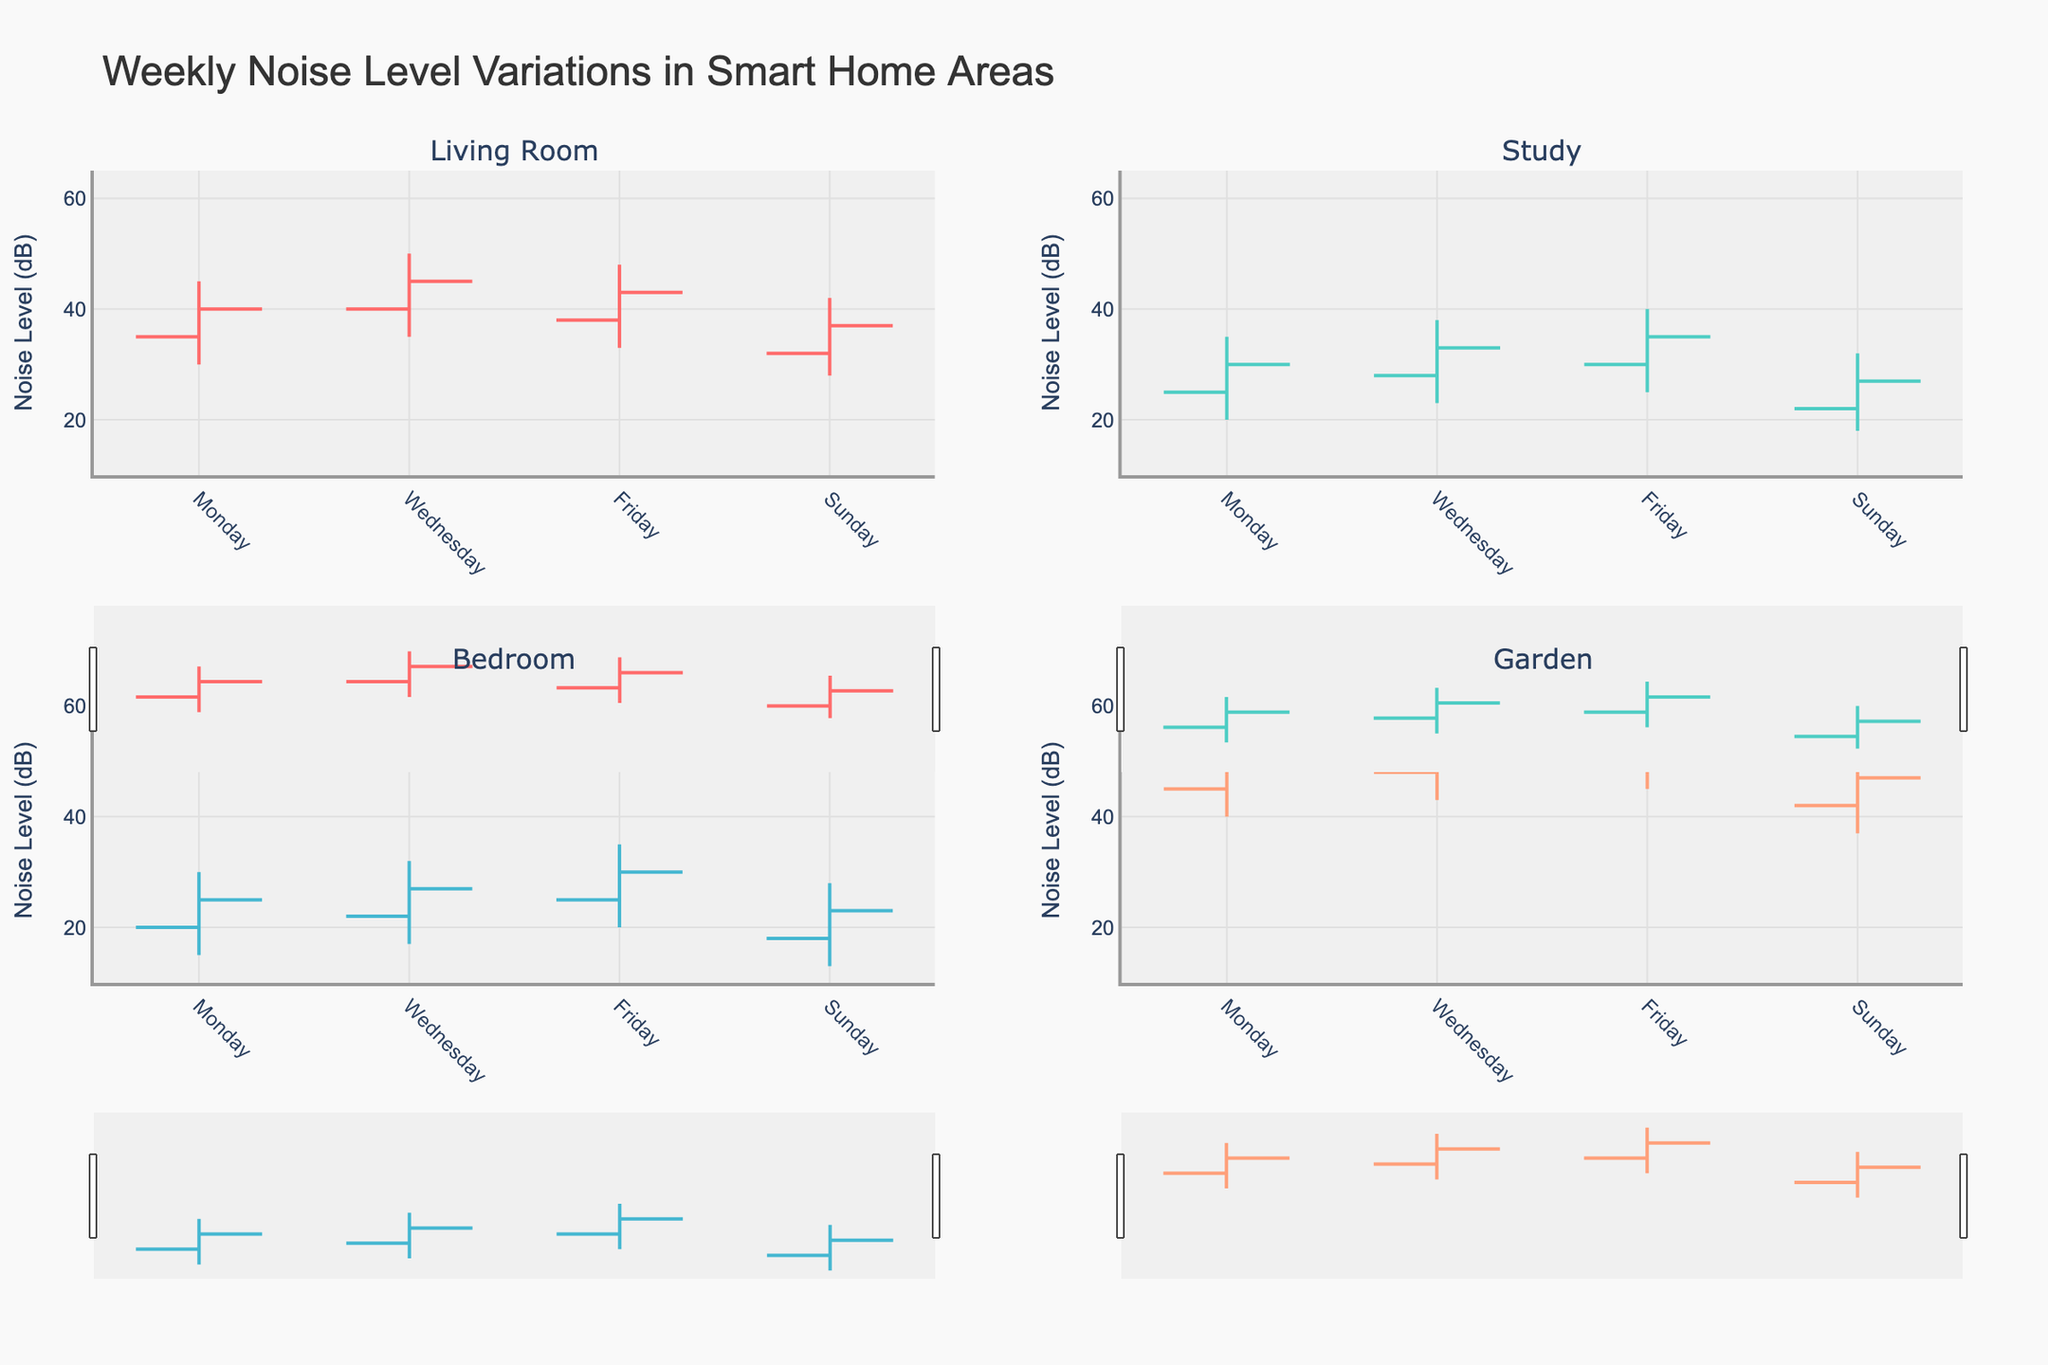What is the title of the figure? The title can be observed at the top of the figure. It reads "Weekly Noise Level Variations in Smart Home Areas".
Answer: Weekly Noise Level Variations in Smart Home Areas Which area had the highest noise level on Wednesday? From the chart, look at the "Wednesday" bar for each area. The highest point corresponds to the Garden which recorded a high of 58 dB.
Answer: Garden What is the lowest noise level recorded in the Study area across the week? Inspect the lowest points of all the bars for the Study area. The lowest point is on Sunday at 18 dB.
Answer: 18 dB Between which two days does the Living Room show the greatest decrease in the closing noise level? Compare the closing noise levels of subsequent days in the Living Room. The highest decrease is from Wednesday (45 dB) to Sunday (37 dB), a drop of 8 dB.
Answer: Wednesday to Sunday What is the average high noise level for the Bedroom during the week? Add up the high values for the Bedroom (30 + 32 + 35 + 28) and divide by 4. The sum is 125, and the average is 125 / 4 = 31.25.
Answer: 31.25 dB How much did the noise level increase in the Garden from Monday to Friday? Look at the opening noise level on Monday (45 dB) and the closing noise level on Friday (55 dB). The increase is 55 - 45 = 10 dB.
Answer: 10 dB Did any area experience both an increase and a decrease in noise levels on the same day? If so, which area(s) and on which day(s)? Check if, for the same day, the open is lower/higher and the close is higher/lower or vice versa. The Garden on Wednesday, open at 48 dB and high at 58 dB but closing at 53 dB, shows both increase and decrease.
Answer: Garden on Wednesday Which day had the highest opening noise level in the Garden? Observe the opening levels in the Garden. The highest opening noise level is on Friday at 50 dB.
Answer: Friday Compare the closing noise levels in the Study area on Monday and Friday. Which day had a higher closing level? Compare the closing values in the Study on Monday (30 dB) and Friday (35 dB). Friday has the higher closing level.
Answer: Friday What is the range of noise levels (high - low) in the Living Room on Friday? For the Living Room on Friday, subtract the low value (33 dB) from the high value (48 dB). The range is 48 - 33 = 15.
Answer: 15 dB 